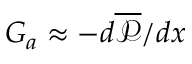<formula> <loc_0><loc_0><loc_500><loc_500>G _ { a } \approx - d \overline { { \mathcal { P } } } / d x</formula> 